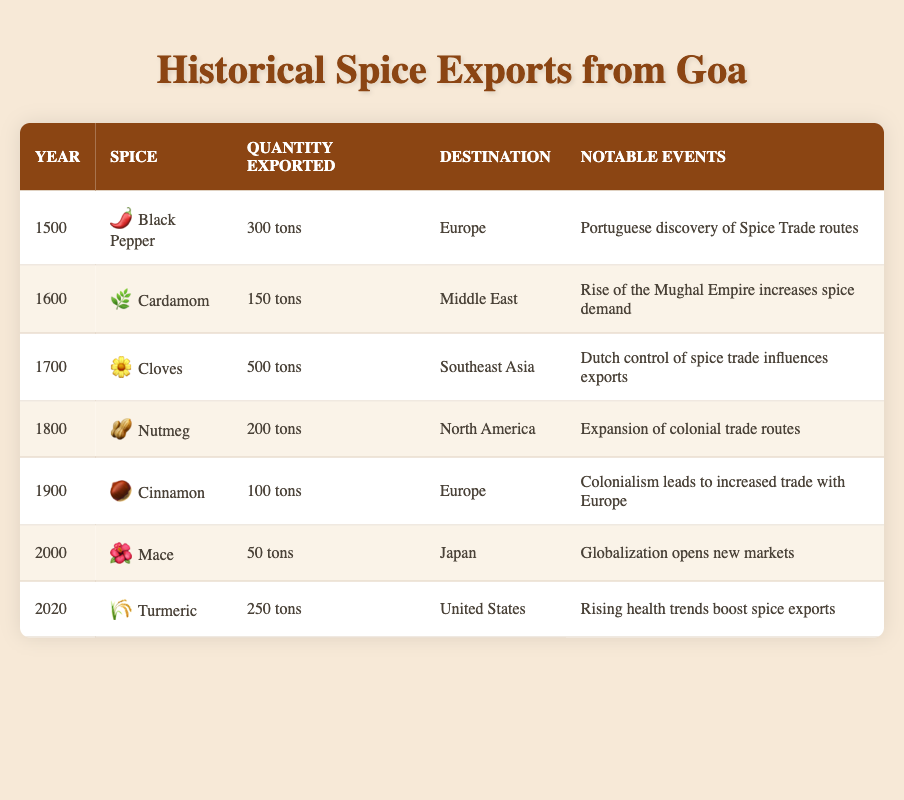What spice was exported the most in 1700? The table indicates that in 1700, Cloves were exported in the highest quantity, which was 500 tons.
Answer: Cloves Which destination received Cinnamon in 1900? The table shows that Cinnamon was exported to Europe in 1900.
Answer: Europe What is the total quantity of spices exported from Goa in the 1800s? The quantities exported in the 1800s were Nutmeg (200 tons) in 1800. Therefore, the total is 200 tons.
Answer: 200 tons Did the quantity of Mace exported in 2000 exceed 100 tons? By checking Mace's quantity in 2000, we see it was 50 tons, which is less than 100 tons. Therefore, the answer is false.
Answer: No How many spices were exported to Europe from 1500 to 1900? Looking at the years 1500 (Black Pepper), and 1900 (Cinnamon), we note that two different spices were exported to Europe during that period.
Answer: 2 spices What was the notable event influencing spice exports in 1600? The notable event listed for the year 1600 is the rise of the Mughal Empire, which increased spice demand.
Answer: Rise of the Mughal Empire If we consider the average quantity of spices exported from Goa over the centuries, including all listed spices, what would that be? The quantities exported were 300, 150, 500, 200, 100, 50, and 250 tons. Summing these gives 1550 tons, divided by 7 (the number of data points) results in an average of approximately 221.43 tons.
Answer: 221.43 tons What spice was exported in the smallest quantity in the year 2000? The table states that Mace was the spice exported in the smallest quantity in the year 2000, at 50 tons.
Answer: Mace Which spice had the largest export volume decrease from 1700 to 1800? Comparing Cloves (500 tons in 1700) to Nutmeg (200 tons in 1800), we see a decrease of 300 tons. This is the largest decrease in volume.
Answer: Cloves 